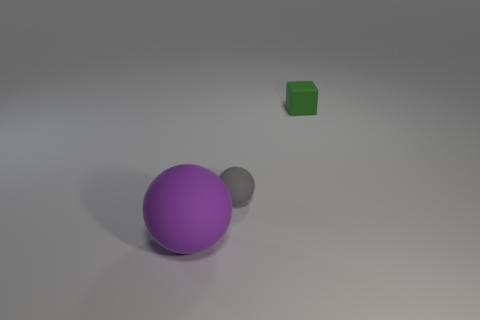Add 3 small brown objects. How many objects exist? 6 Subtract all spheres. How many objects are left? 1 Add 2 gray matte spheres. How many gray matte spheres are left? 3 Add 1 green cubes. How many green cubes exist? 2 Subtract 0 yellow cubes. How many objects are left? 3 Subtract all big purple spheres. Subtract all big gray metallic things. How many objects are left? 2 